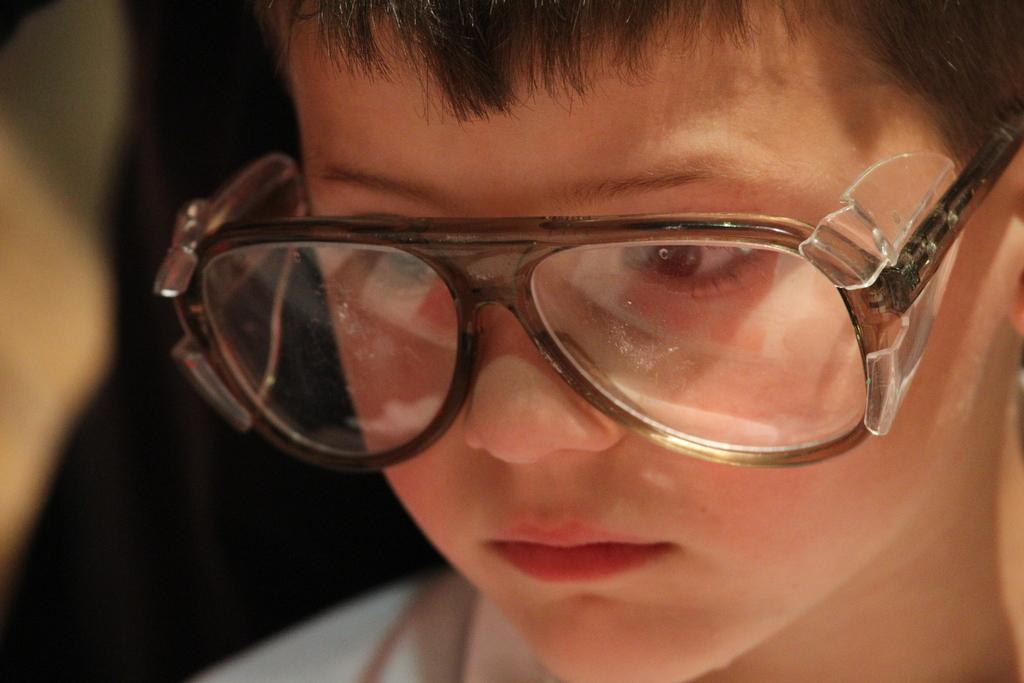Who is the main subject in the picture? There is a boy in the picture. What is the boy doing in the image? The boy is sitting. Where is the boy looking in the image? The boy is looking at the floor. What accessory is the boy wearing in the image? The boy is wearing spectacles. What can be said about the lighting or color scheme of the image? The backdrop of the image is dark. Can you tell me how many buckets are visible in the image? There are no buckets present in the image. What type of glove is the boy wearing in the image? The boy is not wearing any gloves in the image. 